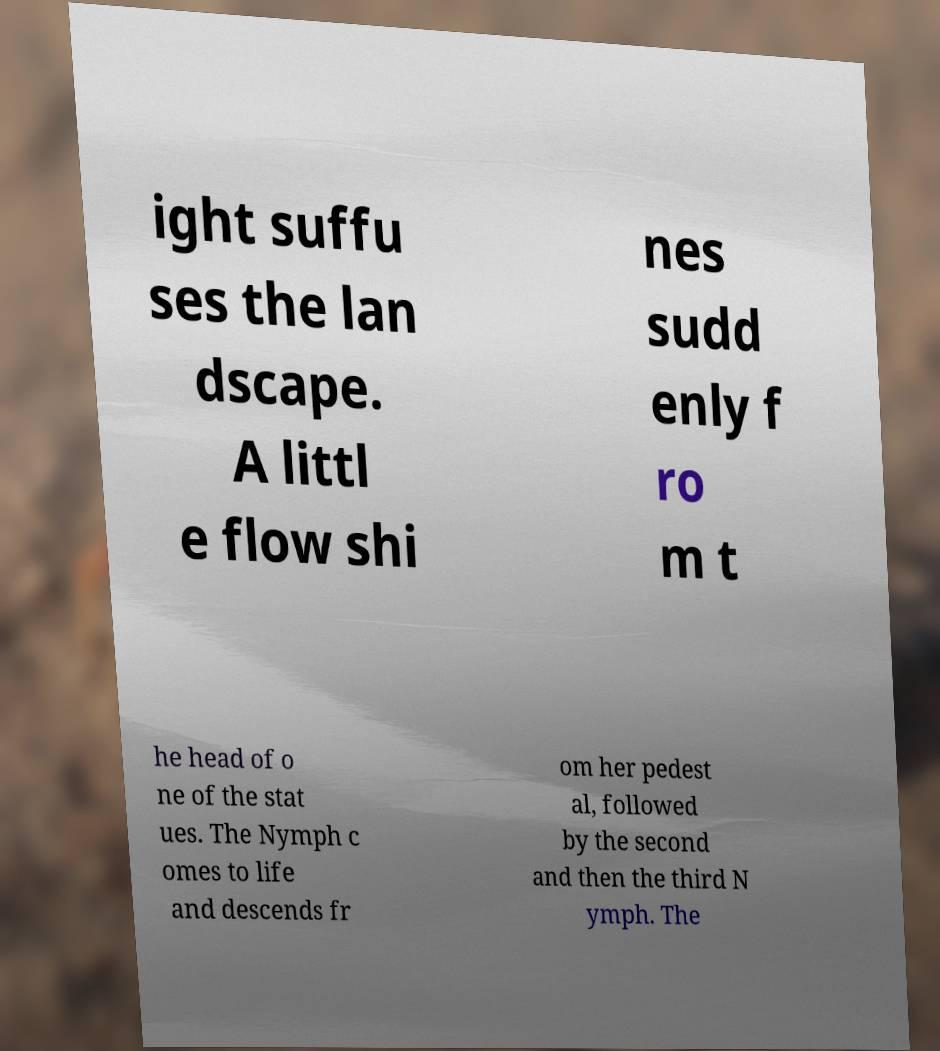Could you extract and type out the text from this image? ight suffu ses the lan dscape. A littl e flow shi nes sudd enly f ro m t he head of o ne of the stat ues. The Nymph c omes to life and descends fr om her pedest al, followed by the second and then the third N ymph. The 